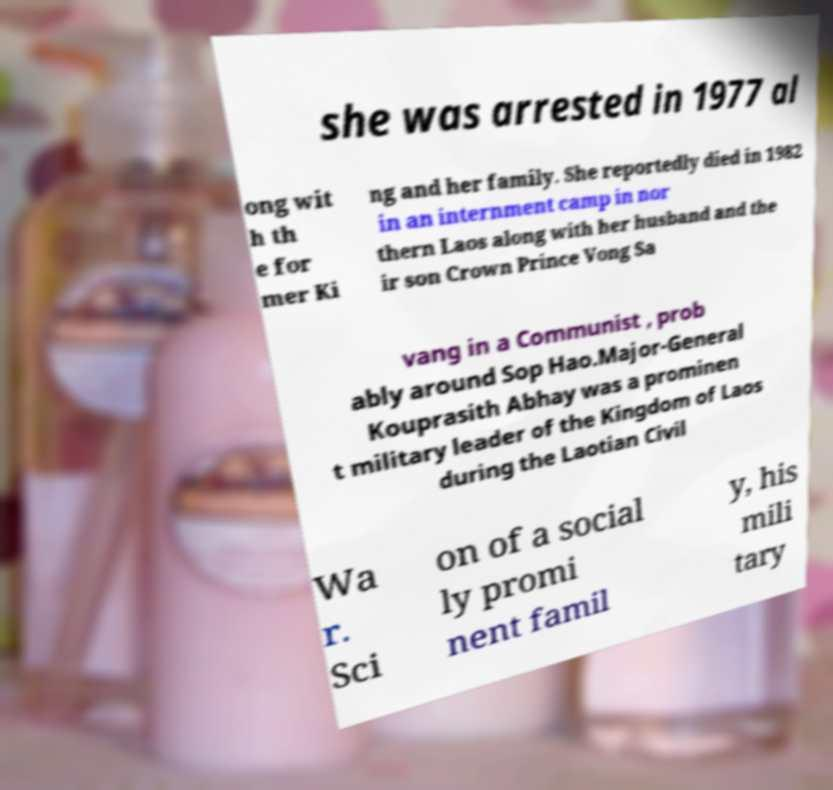Could you assist in decoding the text presented in this image and type it out clearly? she was arrested in 1977 al ong wit h th e for mer Ki ng and her family. She reportedly died in 1982 in an internment camp in nor thern Laos along with her husband and the ir son Crown Prince Vong Sa vang in a Communist , prob ably around Sop Hao.Major-General Kouprasith Abhay was a prominen t military leader of the Kingdom of Laos during the Laotian Civil Wa r. Sci on of a social ly promi nent famil y, his mili tary 